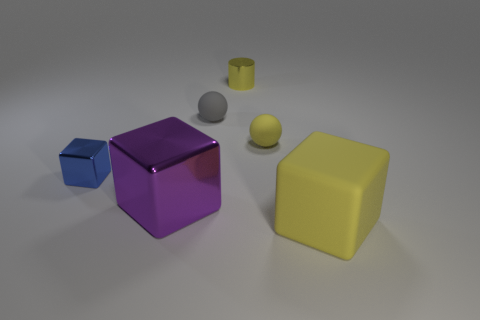There is a object that is in front of the tiny blue thing and right of the purple block; what material is it?
Your answer should be very brief. Rubber. The sphere left of the yellow matte thing to the left of the matte thing that is in front of the tiny blue thing is what color?
Your answer should be very brief. Gray. How many purple objects are either blocks or big shiny things?
Give a very brief answer. 1. How many other things are there of the same size as the yellow cube?
Provide a succinct answer. 1. What number of purple matte cylinders are there?
Provide a succinct answer. 0. Is there anything else that has the same shape as the tiny yellow metal thing?
Give a very brief answer. No. Are the yellow thing in front of the purple shiny cube and the sphere on the left side of the tiny yellow matte object made of the same material?
Ensure brevity in your answer.  Yes. What material is the cylinder?
Provide a succinct answer. Metal. How many small blue cubes are the same material as the cylinder?
Provide a short and direct response. 1. How many metallic things are small brown blocks or cylinders?
Your answer should be very brief. 1. 